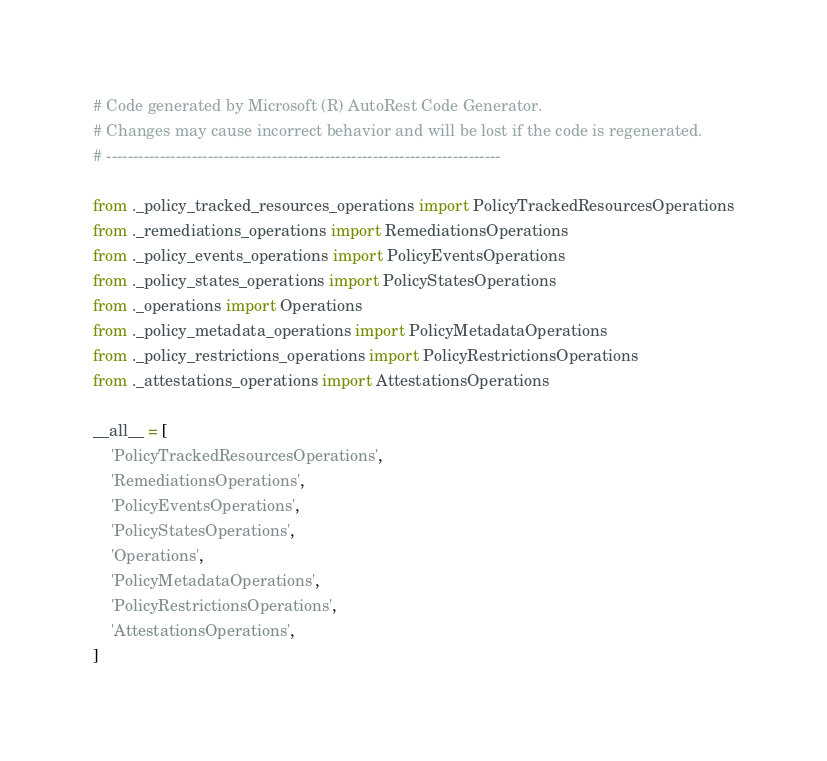Convert code to text. <code><loc_0><loc_0><loc_500><loc_500><_Python_># Code generated by Microsoft (R) AutoRest Code Generator.
# Changes may cause incorrect behavior and will be lost if the code is regenerated.
# --------------------------------------------------------------------------

from ._policy_tracked_resources_operations import PolicyTrackedResourcesOperations
from ._remediations_operations import RemediationsOperations
from ._policy_events_operations import PolicyEventsOperations
from ._policy_states_operations import PolicyStatesOperations
from ._operations import Operations
from ._policy_metadata_operations import PolicyMetadataOperations
from ._policy_restrictions_operations import PolicyRestrictionsOperations
from ._attestations_operations import AttestationsOperations

__all__ = [
    'PolicyTrackedResourcesOperations',
    'RemediationsOperations',
    'PolicyEventsOperations',
    'PolicyStatesOperations',
    'Operations',
    'PolicyMetadataOperations',
    'PolicyRestrictionsOperations',
    'AttestationsOperations',
]
</code> 